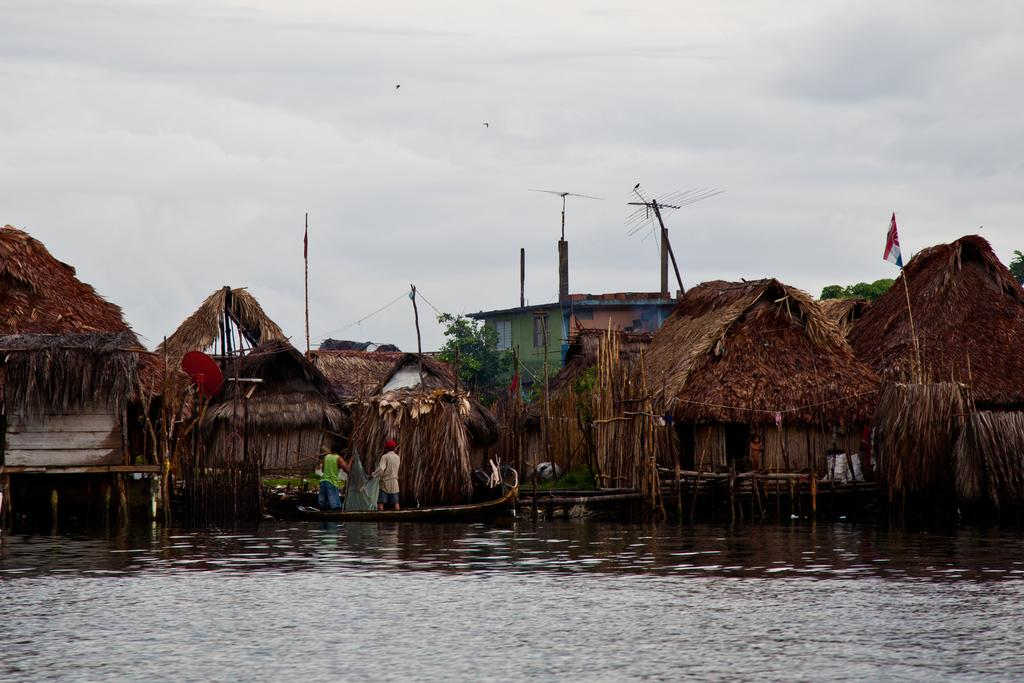What is the main subject of the image? There are many hats in the image. What type of structure can be seen in the image? There is a building in the image. What is visible at the top of the image? The sky is visible at the top of the image. What is visible at the bottom of the image? There is water visible at the bottom of the image. What are the two men doing in the image? The two men are standing in a boat. How many marbles are being held by the feet of the friend in the image? There is no friend or marbles present in the image. 